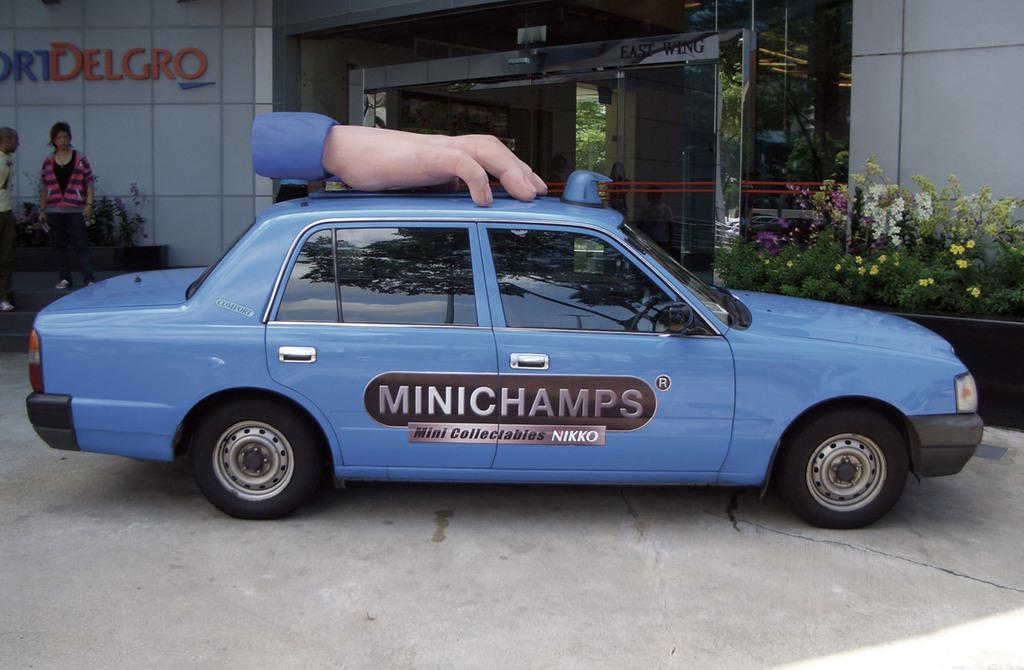Provide a one-sentence caption for the provided image. a Mini champs car with the advertisement on the side. 